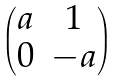Convert formula to latex. <formula><loc_0><loc_0><loc_500><loc_500>\begin{pmatrix} a & 1 \\ 0 & - a \end{pmatrix}</formula> 